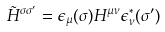<formula> <loc_0><loc_0><loc_500><loc_500>\tilde { H } ^ { \sigma \sigma ^ { \prime } } = \epsilon _ { \mu } ( \sigma ) H ^ { \mu \nu } \epsilon _ { \nu } ^ { \ast } ( \sigma ^ { \prime } )</formula> 